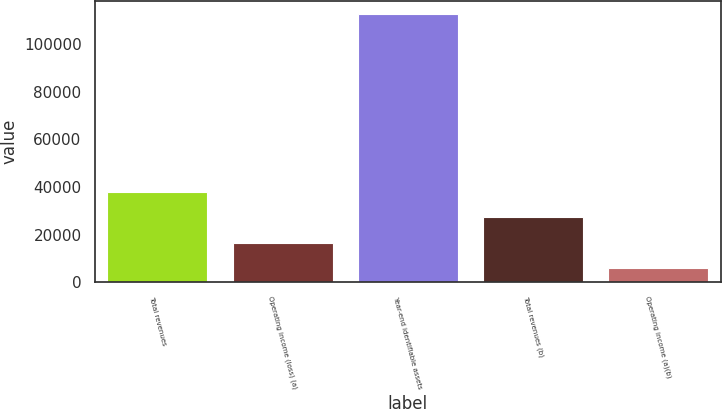Convert chart to OTSL. <chart><loc_0><loc_0><loc_500><loc_500><bar_chart><fcel>Total revenues<fcel>Operating income (loss) (a)<fcel>Year-end identifiable assets<fcel>Total revenues (b)<fcel>Operating income (a)(b)<nl><fcel>38102<fcel>16528<fcel>112675<fcel>27419<fcel>5845<nl></chart> 